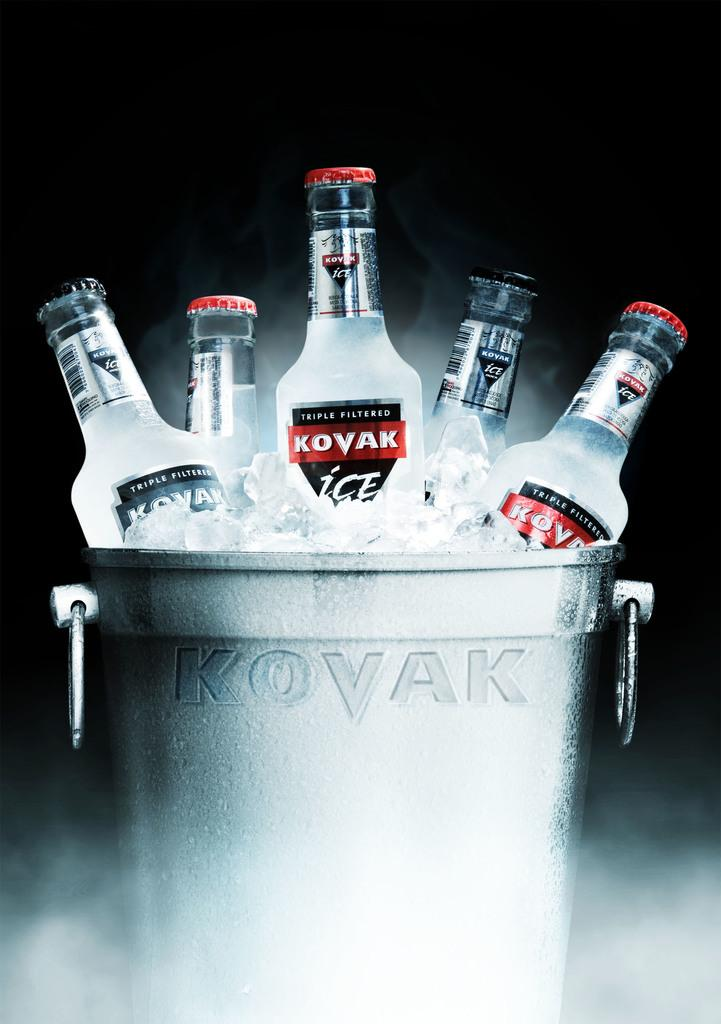Provide a one-sentence caption for the provided image. Bottles of Kovak sitting in ice inside of a cooler. 